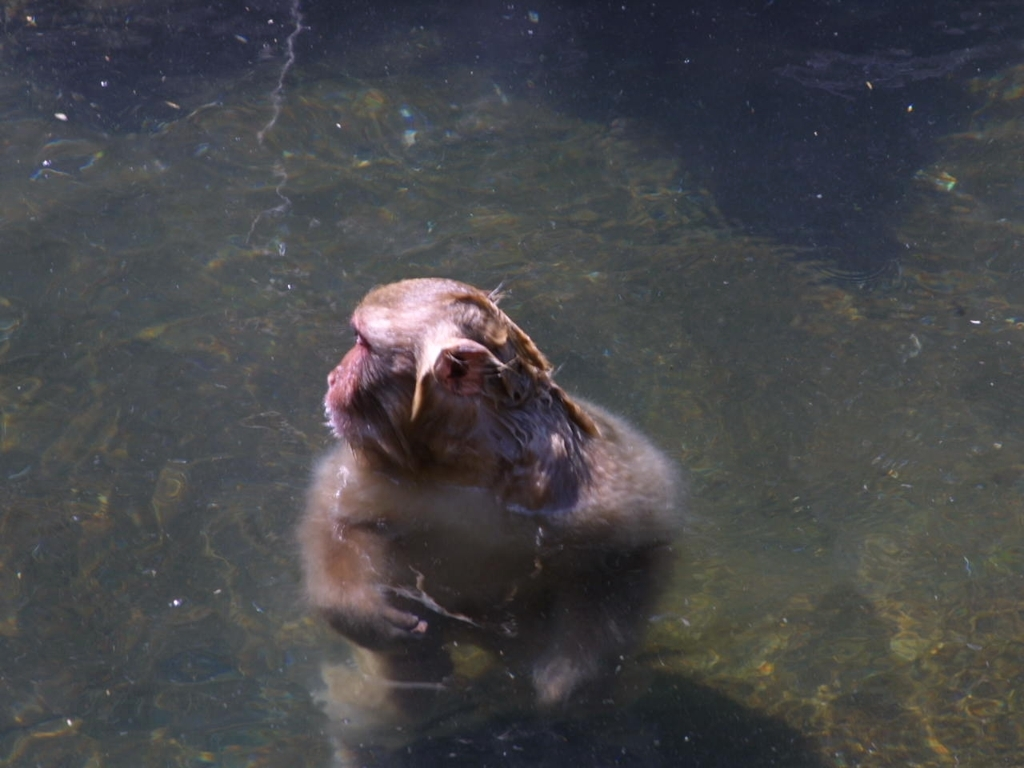Is the exposure adequate? The image appears somewhat overexposed, primarily around the water's surface which has resulted in a loss of detail in those areas. However, the main subject, which seems to be an animal, possibly a monkey, is visible with moderate clarity. 